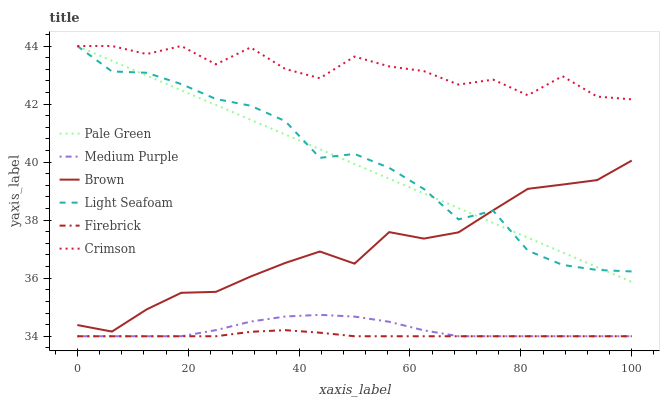Does Firebrick have the minimum area under the curve?
Answer yes or no. Yes. Does Crimson have the maximum area under the curve?
Answer yes or no. Yes. Does Medium Purple have the minimum area under the curve?
Answer yes or no. No. Does Medium Purple have the maximum area under the curve?
Answer yes or no. No. Is Pale Green the smoothest?
Answer yes or no. Yes. Is Crimson the roughest?
Answer yes or no. Yes. Is Firebrick the smoothest?
Answer yes or no. No. Is Firebrick the roughest?
Answer yes or no. No. Does Firebrick have the lowest value?
Answer yes or no. Yes. Does Pale Green have the lowest value?
Answer yes or no. No. Does Light Seafoam have the highest value?
Answer yes or no. Yes. Does Medium Purple have the highest value?
Answer yes or no. No. Is Brown less than Crimson?
Answer yes or no. Yes. Is Light Seafoam greater than Firebrick?
Answer yes or no. Yes. Does Pale Green intersect Brown?
Answer yes or no. Yes. Is Pale Green less than Brown?
Answer yes or no. No. Is Pale Green greater than Brown?
Answer yes or no. No. Does Brown intersect Crimson?
Answer yes or no. No. 